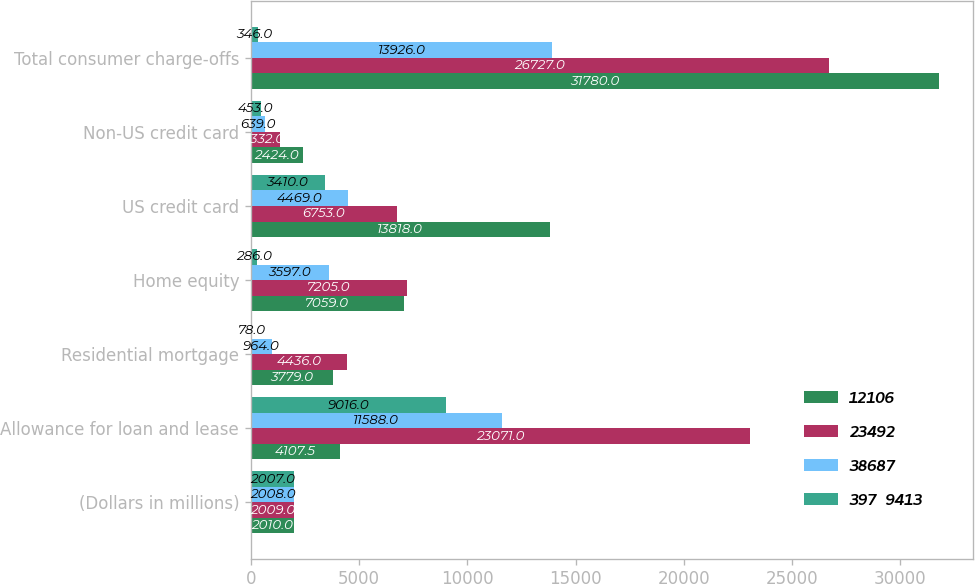Convert chart. <chart><loc_0><loc_0><loc_500><loc_500><stacked_bar_chart><ecel><fcel>(Dollars in millions)<fcel>Allowance for loan and lease<fcel>Residential mortgage<fcel>Home equity<fcel>US credit card<fcel>Non-US credit card<fcel>Total consumer charge-offs<nl><fcel>12106<fcel>2010<fcel>4107.5<fcel>3779<fcel>7059<fcel>13818<fcel>2424<fcel>31780<nl><fcel>23492<fcel>2009<fcel>23071<fcel>4436<fcel>7205<fcel>6753<fcel>1332<fcel>26727<nl><fcel>38687<fcel>2008<fcel>11588<fcel>964<fcel>3597<fcel>4469<fcel>639<fcel>13926<nl><fcel>397  9413<fcel>2007<fcel>9016<fcel>78<fcel>286<fcel>3410<fcel>453<fcel>346<nl></chart> 